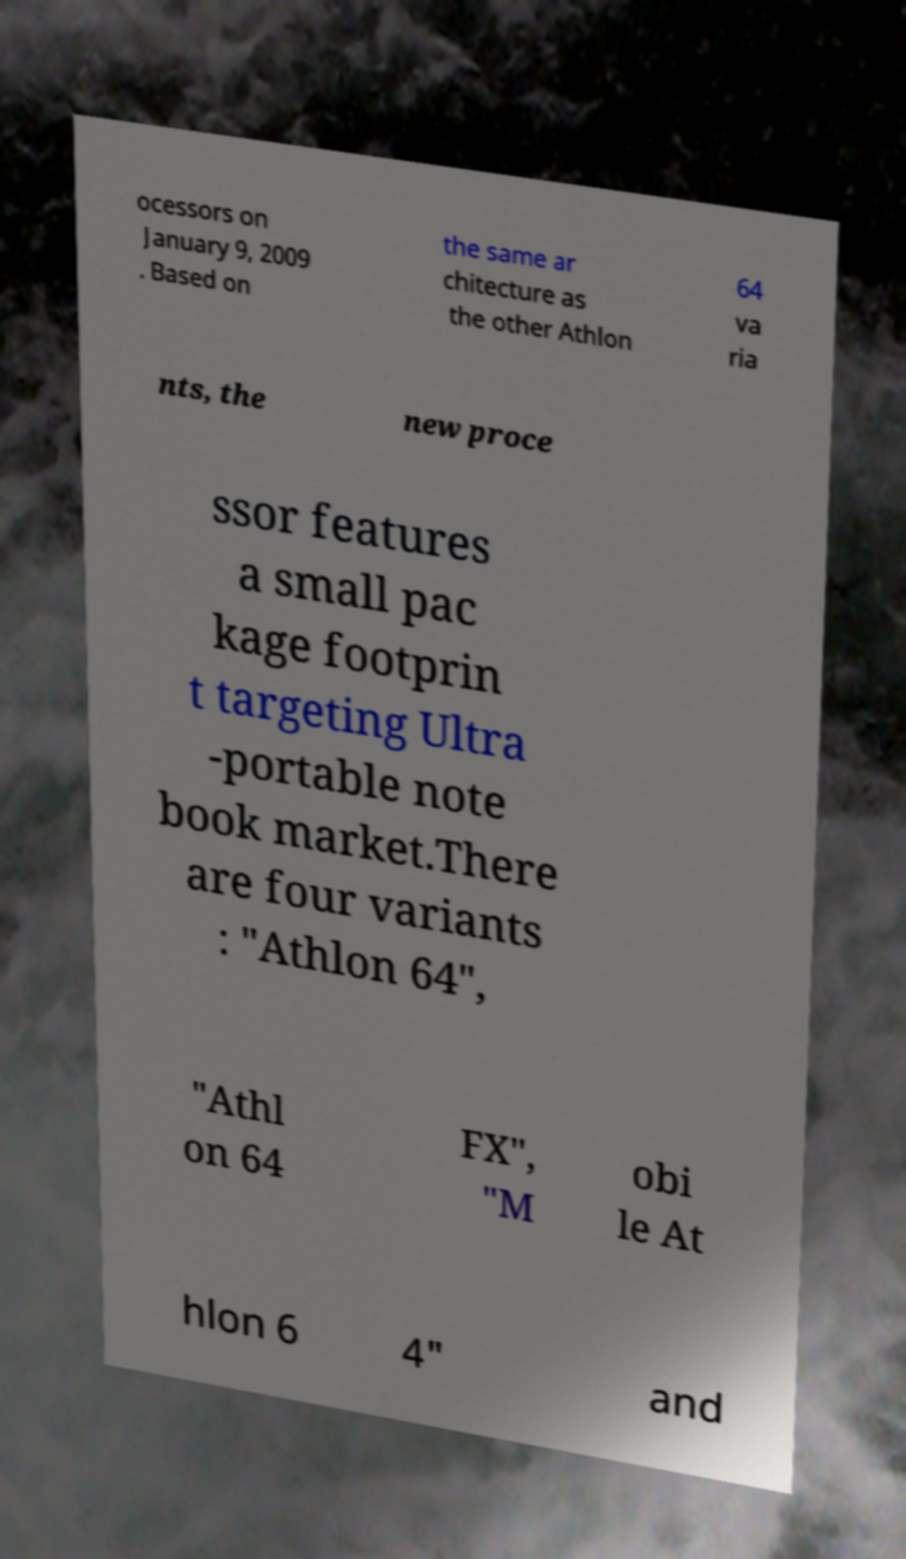Please read and relay the text visible in this image. What does it say? ocessors on January 9, 2009 . Based on the same ar chitecture as the other Athlon 64 va ria nts, the new proce ssor features a small pac kage footprin t targeting Ultra -portable note book market.There are four variants : "Athlon 64", "Athl on 64 FX", "M obi le At hlon 6 4" and 